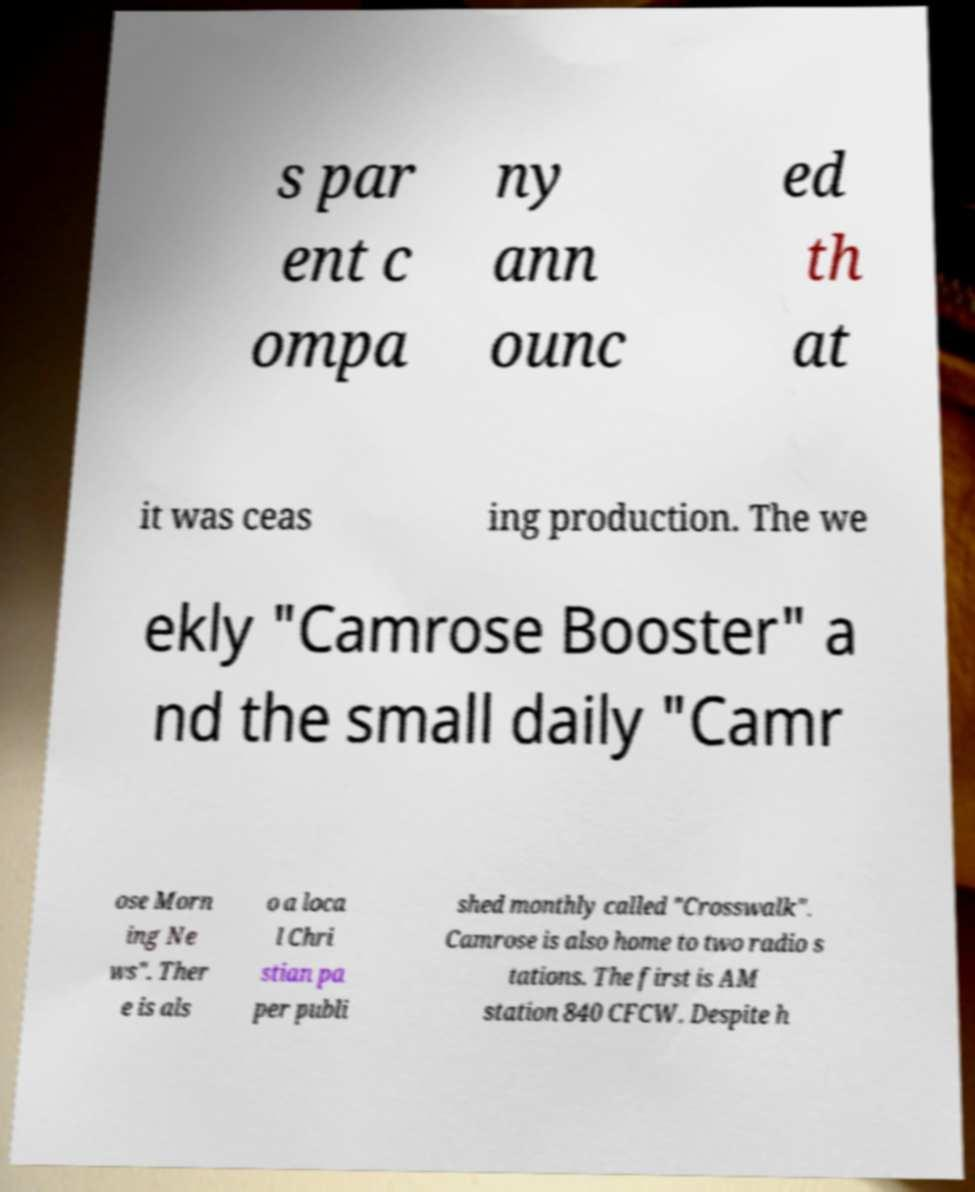Could you extract and type out the text from this image? s par ent c ompa ny ann ounc ed th at it was ceas ing production. The we ekly "Camrose Booster" a nd the small daily "Camr ose Morn ing Ne ws". Ther e is als o a loca l Chri stian pa per publi shed monthly called "Crosswalk". Camrose is also home to two radio s tations. The first is AM station 840 CFCW. Despite h 